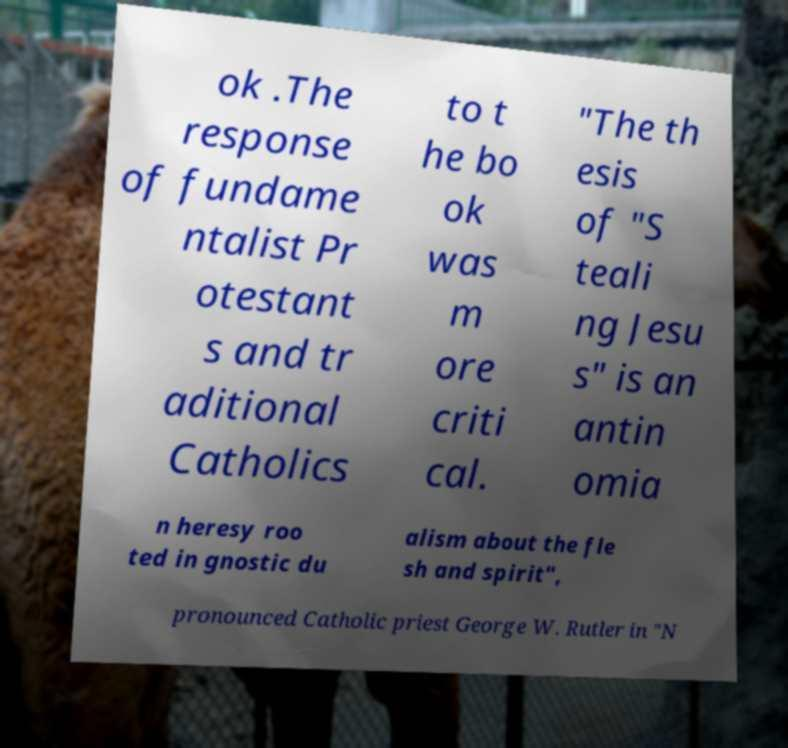Can you accurately transcribe the text from the provided image for me? ok .The response of fundame ntalist Pr otestant s and tr aditional Catholics to t he bo ok was m ore criti cal. "The th esis of "S teali ng Jesu s" is an antin omia n heresy roo ted in gnostic du alism about the fle sh and spirit", pronounced Catholic priest George W. Rutler in "N 